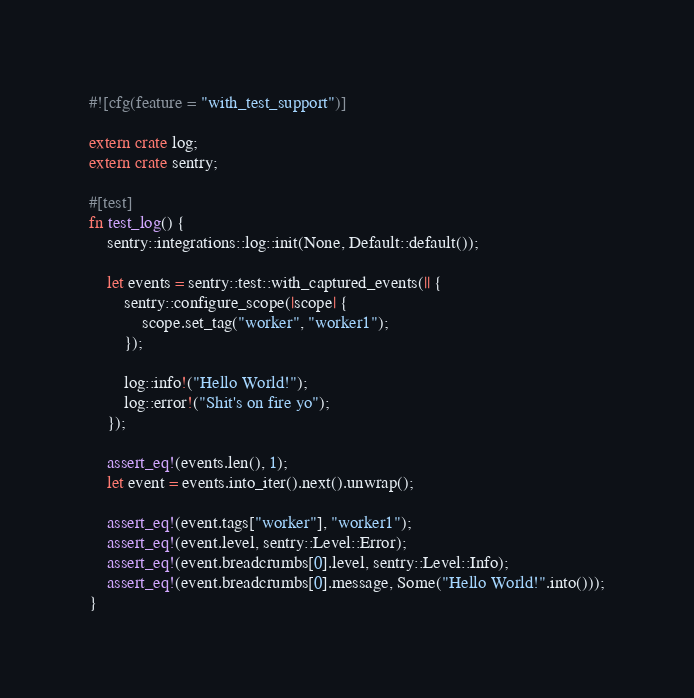<code> <loc_0><loc_0><loc_500><loc_500><_Rust_>#![cfg(feature = "with_test_support")]

extern crate log;
extern crate sentry;

#[test]
fn test_log() {
    sentry::integrations::log::init(None, Default::default());

    let events = sentry::test::with_captured_events(|| {
        sentry::configure_scope(|scope| {
            scope.set_tag("worker", "worker1");
        });

        log::info!("Hello World!");
        log::error!("Shit's on fire yo");
    });

    assert_eq!(events.len(), 1);
    let event = events.into_iter().next().unwrap();

    assert_eq!(event.tags["worker"], "worker1");
    assert_eq!(event.level, sentry::Level::Error);
    assert_eq!(event.breadcrumbs[0].level, sentry::Level::Info);
    assert_eq!(event.breadcrumbs[0].message, Some("Hello World!".into()));
}
</code> 